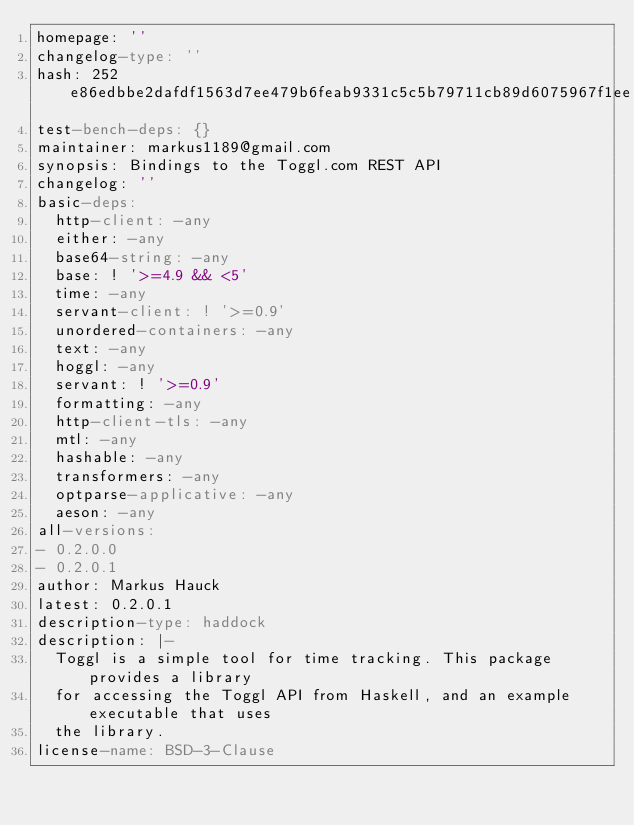Convert code to text. <code><loc_0><loc_0><loc_500><loc_500><_YAML_>homepage: ''
changelog-type: ''
hash: 252e86edbbe2dafdf1563d7ee479b6feab9331c5c5b79711cb89d6075967f1ee
test-bench-deps: {}
maintainer: markus1189@gmail.com
synopsis: Bindings to the Toggl.com REST API
changelog: ''
basic-deps:
  http-client: -any
  either: -any
  base64-string: -any
  base: ! '>=4.9 && <5'
  time: -any
  servant-client: ! '>=0.9'
  unordered-containers: -any
  text: -any
  hoggl: -any
  servant: ! '>=0.9'
  formatting: -any
  http-client-tls: -any
  mtl: -any
  hashable: -any
  transformers: -any
  optparse-applicative: -any
  aeson: -any
all-versions:
- 0.2.0.0
- 0.2.0.1
author: Markus Hauck
latest: 0.2.0.1
description-type: haddock
description: |-
  Toggl is a simple tool for time tracking. This package provides a library
  for accessing the Toggl API from Haskell, and an example executable that uses
  the library.
license-name: BSD-3-Clause
</code> 